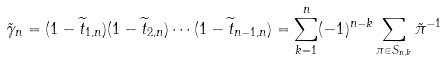<formula> <loc_0><loc_0><loc_500><loc_500>\tilde { \gamma } _ { n } = ( 1 - \widetilde { t } _ { 1 , n } ) ( 1 - \widetilde { t } _ { 2 , n } ) \cdots ( 1 - \widetilde { t } _ { n - 1 , n } ) = \sum _ { k = 1 } ^ { n } ( - 1 ) ^ { n - k } \sum _ { \pi \in S _ { n , k } } \tilde { \pi } ^ { - 1 }</formula> 